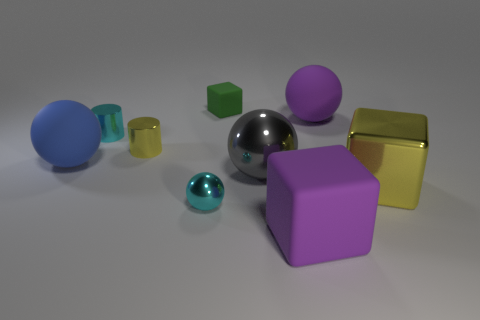Subtract all matte blocks. How many blocks are left? 1 Subtract 3 balls. How many balls are left? 1 Add 1 big matte spheres. How many objects exist? 10 Subtract all purple cubes. How many cubes are left? 2 Subtract 0 yellow spheres. How many objects are left? 9 Subtract all balls. How many objects are left? 5 Subtract all purple cylinders. Subtract all blue cubes. How many cylinders are left? 2 Subtract all tiny red metal spheres. Subtract all gray spheres. How many objects are left? 8 Add 2 big spheres. How many big spheres are left? 5 Add 8 large purple rubber balls. How many large purple rubber balls exist? 9 